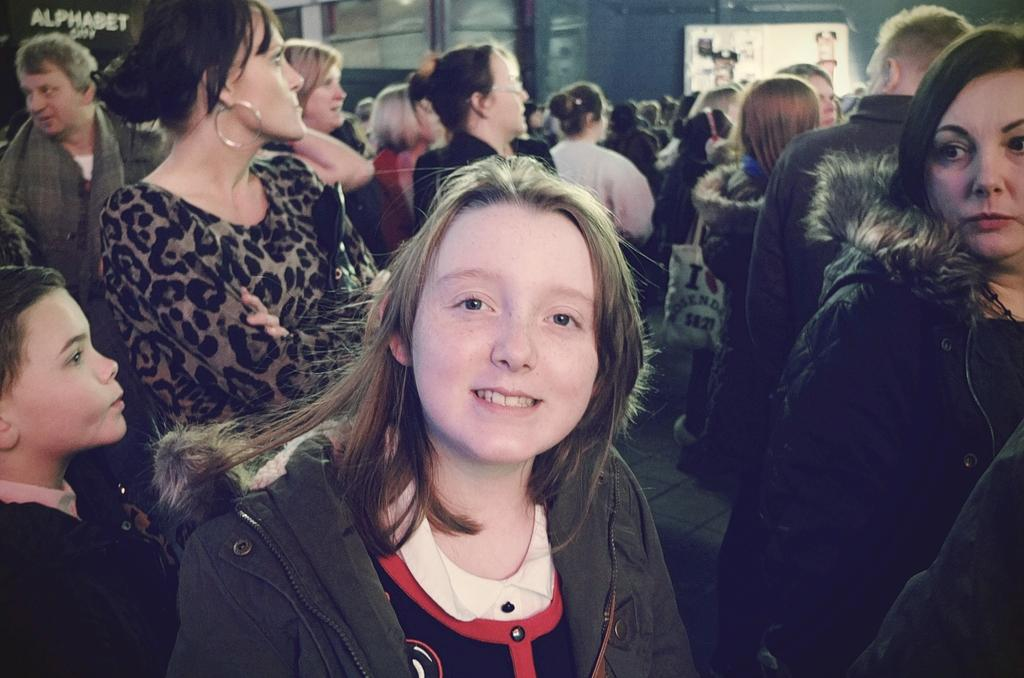Who is the main subject in the image? There is a girl in the image. What is the girl's expression in the image? The girl is smiling in the image. What can be seen in the background of the image? There is a group of people standing in the background of the image, and they are standing on the floor. There is also a wall and objects visible in the background. What type of treatment is the girl receiving in the image? There is no indication in the image that the girl is receiving any treatment; she is simply smiling. 